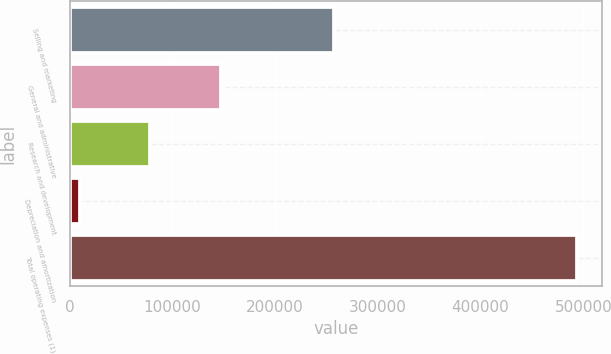<chart> <loc_0><loc_0><loc_500><loc_500><bar_chart><fcel>Selling and marketing<fcel>General and administrative<fcel>Research and development<fcel>Depreciation and amortization<fcel>Total operating expenses (1)<nl><fcel>257329<fcel>147260<fcel>78184<fcel>10634<fcel>493407<nl></chart> 